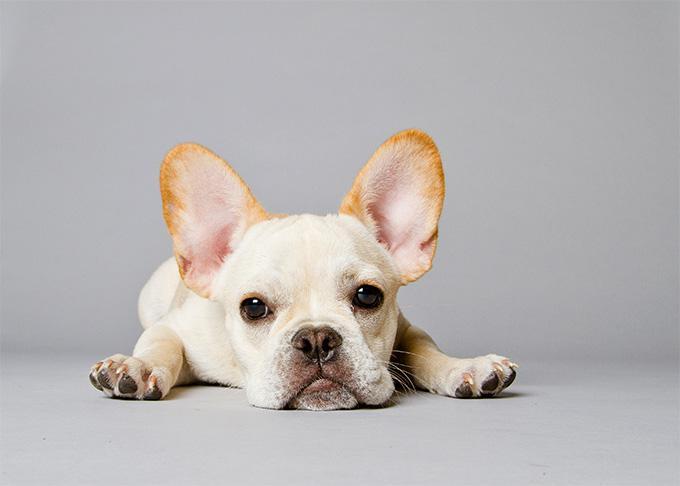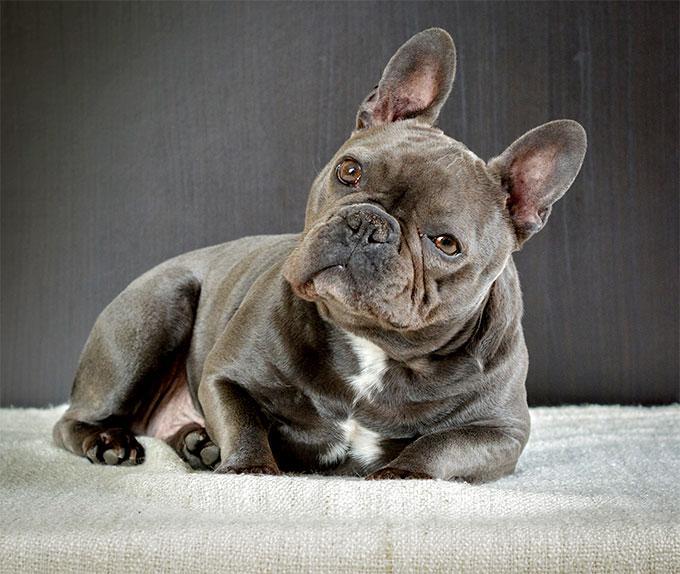The first image is the image on the left, the second image is the image on the right. Given the left and right images, does the statement "An image shows a gray dog with a white mark on its chest." hold true? Answer yes or no. Yes. 